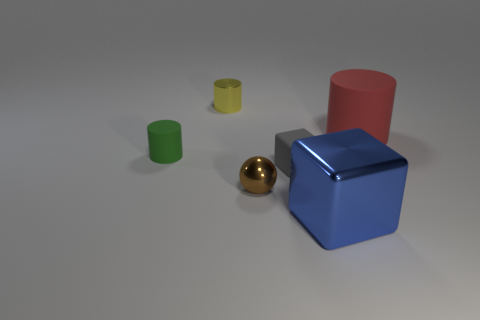What time of day does this scene suggest, based on lighting and shadows? The scene doesn't provide conclusive evidence of the time of day, as it appears to be an artificially lit setup with a soft and diffused light source above and to the left, casting gentle shadows to the right of the objects. 